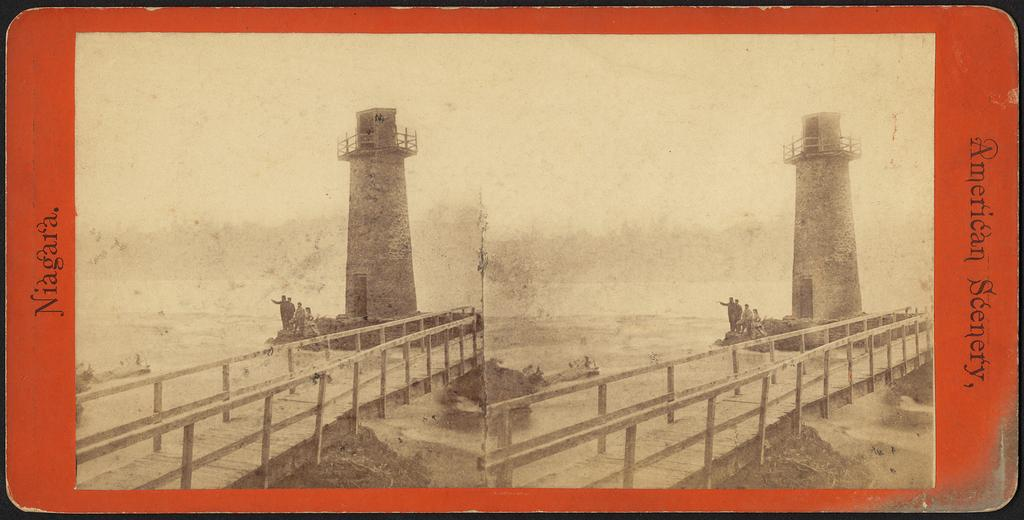<image>
Create a compact narrative representing the image presented. A card with pics of a lighthouse tagged American Scenery. 